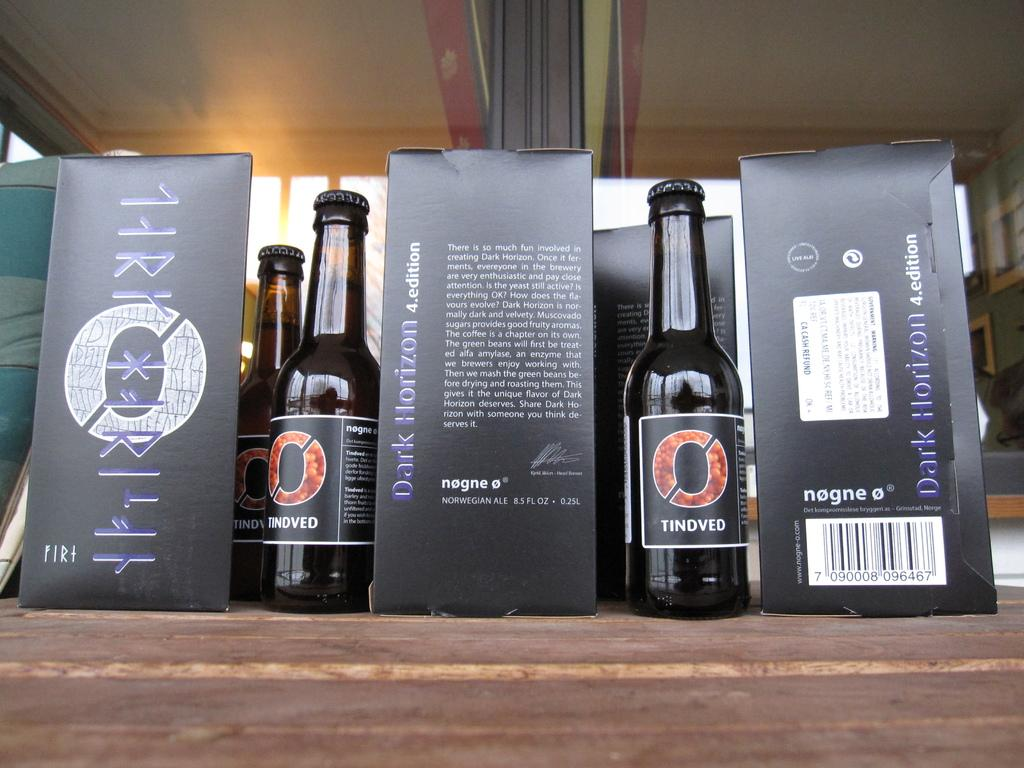<image>
Create a compact narrative representing the image presented. several boxes and bottles of Dark Horizon beer are on display 